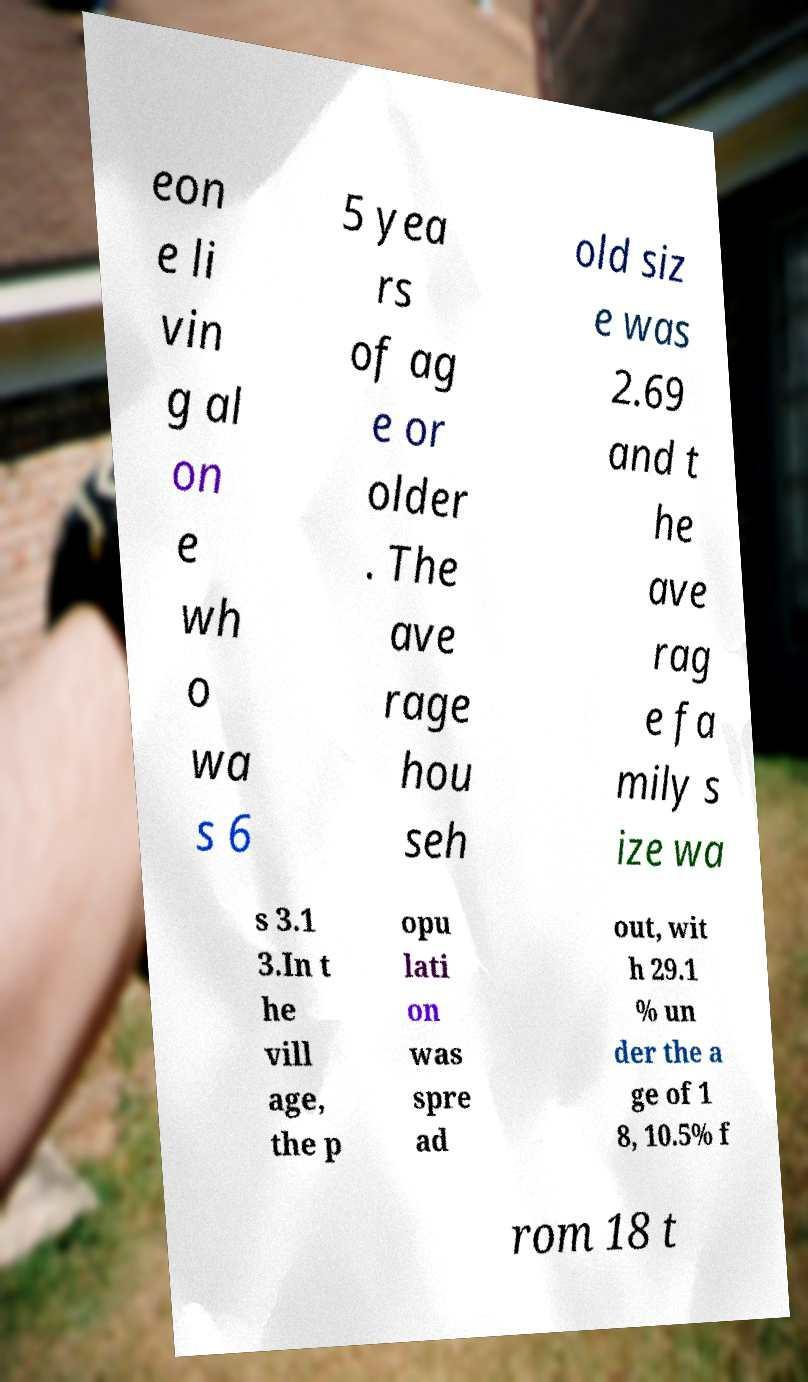For documentation purposes, I need the text within this image transcribed. Could you provide that? eon e li vin g al on e wh o wa s 6 5 yea rs of ag e or older . The ave rage hou seh old siz e was 2.69 and t he ave rag e fa mily s ize wa s 3.1 3.In t he vill age, the p opu lati on was spre ad out, wit h 29.1 % un der the a ge of 1 8, 10.5% f rom 18 t 